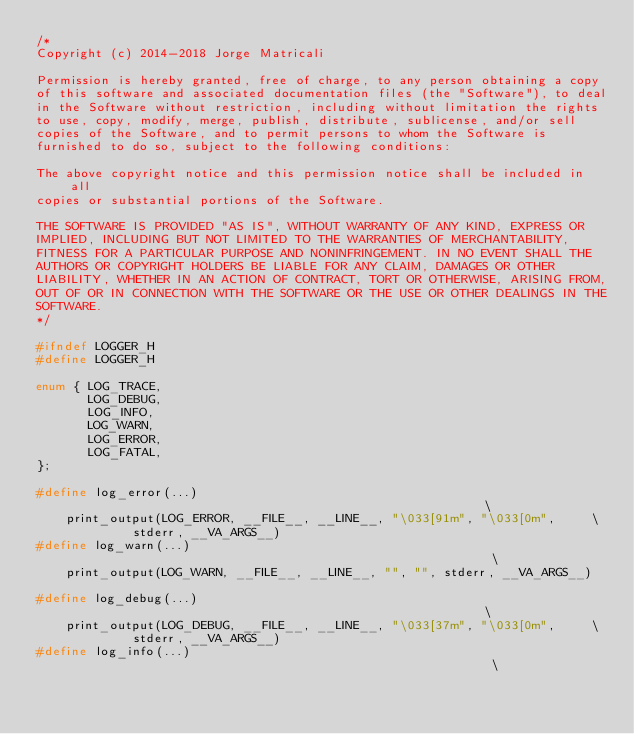<code> <loc_0><loc_0><loc_500><loc_500><_C_>/*
Copyright (c) 2014-2018 Jorge Matricali

Permission is hereby granted, free of charge, to any person obtaining a copy
of this software and associated documentation files (the "Software"), to deal
in the Software without restriction, including without limitation the rights
to use, copy, modify, merge, publish, distribute, sublicense, and/or sell
copies of the Software, and to permit persons to whom the Software is
furnished to do so, subject to the following conditions:

The above copyright notice and this permission notice shall be included in all
copies or substantial portions of the Software.

THE SOFTWARE IS PROVIDED "AS IS", WITHOUT WARRANTY OF ANY KIND, EXPRESS OR
IMPLIED, INCLUDING BUT NOT LIMITED TO THE WARRANTIES OF MERCHANTABILITY,
FITNESS FOR A PARTICULAR PURPOSE AND NONINFRINGEMENT. IN NO EVENT SHALL THE
AUTHORS OR COPYRIGHT HOLDERS BE LIABLE FOR ANY CLAIM, DAMAGES OR OTHER
LIABILITY, WHETHER IN AN ACTION OF CONTRACT, TORT OR OTHERWISE, ARISING FROM,
OUT OF OR IN CONNECTION WITH THE SOFTWARE OR THE USE OR OTHER DEALINGS IN THE
SOFTWARE.
*/

#ifndef LOGGER_H
#define LOGGER_H

enum { LOG_TRACE,
       LOG_DEBUG,
       LOG_INFO,
       LOG_WARN,
       LOG_ERROR,
       LOG_FATAL,
};

#define log_error(...)                                                         \
	print_output(LOG_ERROR, __FILE__, __LINE__, "\033[91m", "\033[0m",     \
		     stderr, __VA_ARGS__)
#define log_warn(...)                                                          \
	print_output(LOG_WARN, __FILE__, __LINE__, "", "", stderr, __VA_ARGS__)

#define log_debug(...)                                                         \
	print_output(LOG_DEBUG, __FILE__, __LINE__, "\033[37m", "\033[0m",     \
		     stderr, __VA_ARGS__)
#define log_info(...)                                                          \</code> 